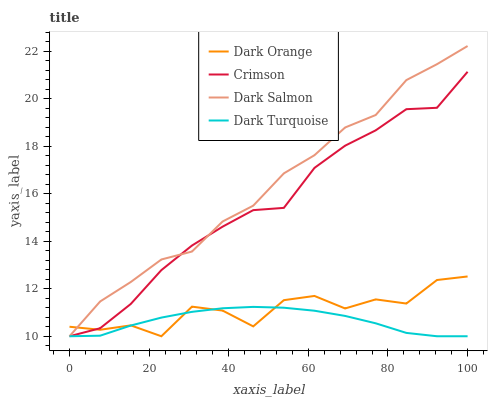Does Dark Turquoise have the minimum area under the curve?
Answer yes or no. Yes. Does Dark Salmon have the maximum area under the curve?
Answer yes or no. Yes. Does Dark Orange have the minimum area under the curve?
Answer yes or no. No. Does Dark Orange have the maximum area under the curve?
Answer yes or no. No. Is Dark Turquoise the smoothest?
Answer yes or no. Yes. Is Dark Orange the roughest?
Answer yes or no. Yes. Is Dark Salmon the smoothest?
Answer yes or no. No. Is Dark Salmon the roughest?
Answer yes or no. No. Does Crimson have the lowest value?
Answer yes or no. Yes. Does Dark Salmon have the highest value?
Answer yes or no. Yes. Does Dark Orange have the highest value?
Answer yes or no. No. Does Dark Salmon intersect Crimson?
Answer yes or no. Yes. Is Dark Salmon less than Crimson?
Answer yes or no. No. Is Dark Salmon greater than Crimson?
Answer yes or no. No. 